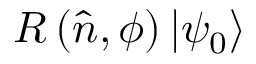Convert formula to latex. <formula><loc_0><loc_0><loc_500><loc_500>R \left ( { \hat { n } } , \phi \right ) \left | \psi _ { 0 } \right \rangle</formula> 